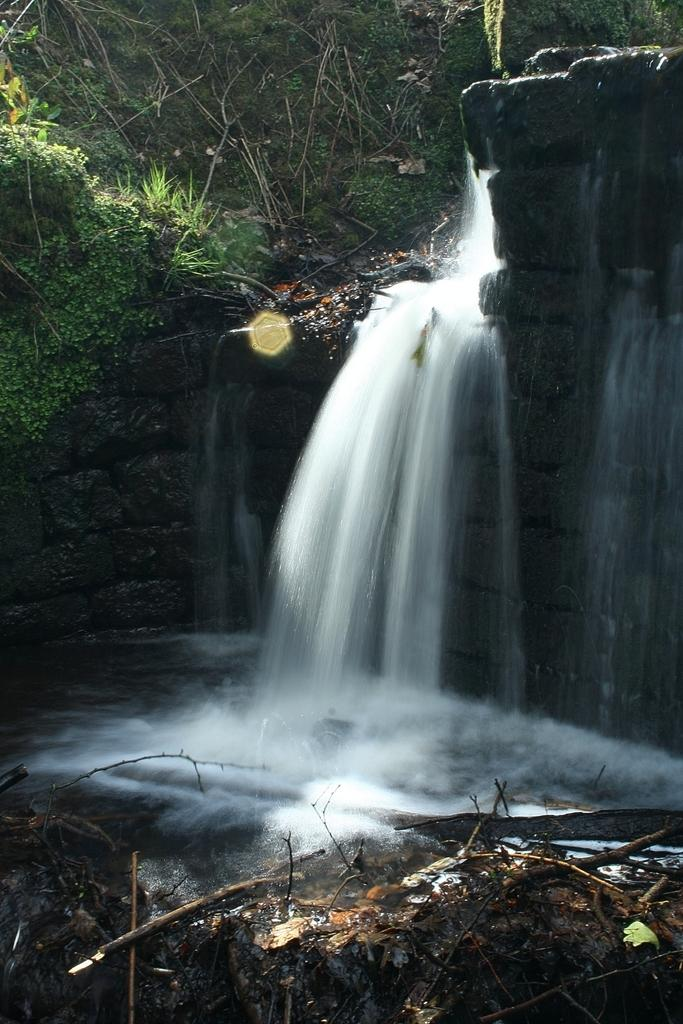What is the main feature in the center of the image? There is a waterfall in the center of the image. What can be seen at the bottom of the image? There are sticks visible at the bottom of the image. What type of vegetation is visible at the top of the image? There is grass visible at the top of the image. What religious symbol can be seen in the image? There is no religious symbol present in the image. How does the sense of smell contribute to the image? The image does not convey any sense of smell, as it is a visual representation. 